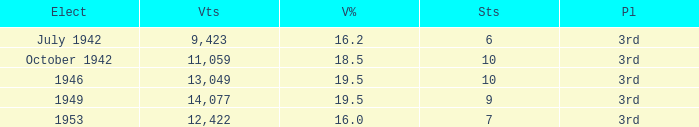Name the vote % for seats of 9 19.5. 